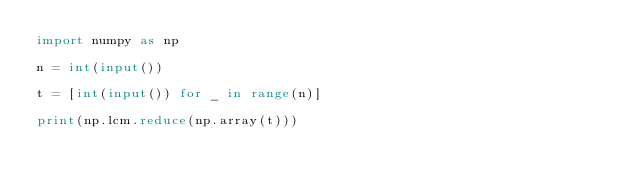<code> <loc_0><loc_0><loc_500><loc_500><_Python_>import numpy as np

n = int(input())

t = [int(input()) for _ in range(n)]

print(np.lcm.reduce(np.array(t)))
</code> 